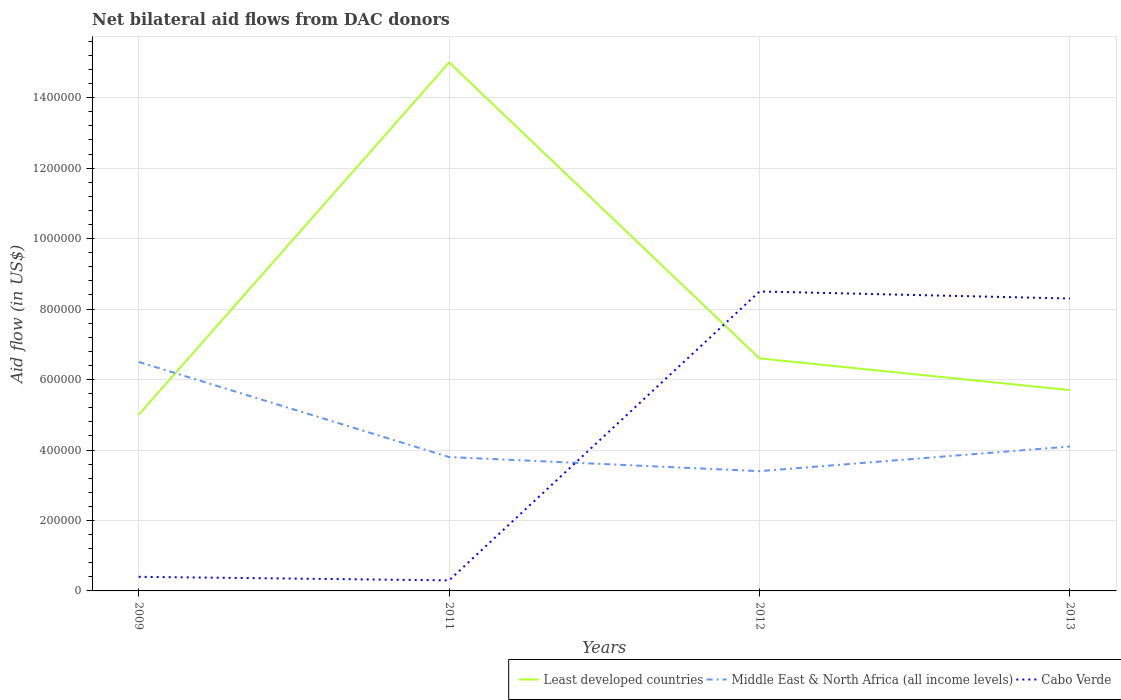Does the line corresponding to Middle East & North Africa (all income levels) intersect with the line corresponding to Least developed countries?
Your answer should be compact. Yes. Is the number of lines equal to the number of legend labels?
Your answer should be compact. Yes. Across all years, what is the maximum net bilateral aid flow in Least developed countries?
Make the answer very short. 5.00e+05. What is the total net bilateral aid flow in Least developed countries in the graph?
Offer a very short reply. -1.60e+05. What is the difference between the highest and the second highest net bilateral aid flow in Cabo Verde?
Your answer should be very brief. 8.20e+05. Is the net bilateral aid flow in Middle East & North Africa (all income levels) strictly greater than the net bilateral aid flow in Least developed countries over the years?
Give a very brief answer. No. Are the values on the major ticks of Y-axis written in scientific E-notation?
Make the answer very short. No. Does the graph contain any zero values?
Offer a very short reply. No. Does the graph contain grids?
Provide a short and direct response. Yes. Where does the legend appear in the graph?
Your response must be concise. Bottom right. What is the title of the graph?
Provide a short and direct response. Net bilateral aid flows from DAC donors. Does "Bulgaria" appear as one of the legend labels in the graph?
Ensure brevity in your answer.  No. What is the label or title of the Y-axis?
Provide a succinct answer. Aid flow (in US$). What is the Aid flow (in US$) in Middle East & North Africa (all income levels) in 2009?
Offer a terse response. 6.50e+05. What is the Aid flow (in US$) in Least developed countries in 2011?
Make the answer very short. 1.50e+06. What is the Aid flow (in US$) of Least developed countries in 2012?
Ensure brevity in your answer.  6.60e+05. What is the Aid flow (in US$) of Cabo Verde in 2012?
Offer a terse response. 8.50e+05. What is the Aid flow (in US$) in Least developed countries in 2013?
Offer a very short reply. 5.70e+05. What is the Aid flow (in US$) of Middle East & North Africa (all income levels) in 2013?
Your answer should be compact. 4.10e+05. What is the Aid flow (in US$) of Cabo Verde in 2013?
Provide a short and direct response. 8.30e+05. Across all years, what is the maximum Aid flow (in US$) in Least developed countries?
Your answer should be compact. 1.50e+06. Across all years, what is the maximum Aid flow (in US$) of Middle East & North Africa (all income levels)?
Make the answer very short. 6.50e+05. Across all years, what is the maximum Aid flow (in US$) of Cabo Verde?
Your answer should be compact. 8.50e+05. Across all years, what is the minimum Aid flow (in US$) in Least developed countries?
Keep it short and to the point. 5.00e+05. Across all years, what is the minimum Aid flow (in US$) in Middle East & North Africa (all income levels)?
Provide a short and direct response. 3.40e+05. Across all years, what is the minimum Aid flow (in US$) of Cabo Verde?
Ensure brevity in your answer.  3.00e+04. What is the total Aid flow (in US$) in Least developed countries in the graph?
Keep it short and to the point. 3.23e+06. What is the total Aid flow (in US$) of Middle East & North Africa (all income levels) in the graph?
Keep it short and to the point. 1.78e+06. What is the total Aid flow (in US$) of Cabo Verde in the graph?
Your answer should be very brief. 1.75e+06. What is the difference between the Aid flow (in US$) of Least developed countries in 2009 and that in 2011?
Your response must be concise. -1.00e+06. What is the difference between the Aid flow (in US$) in Middle East & North Africa (all income levels) in 2009 and that in 2011?
Keep it short and to the point. 2.70e+05. What is the difference between the Aid flow (in US$) of Cabo Verde in 2009 and that in 2012?
Make the answer very short. -8.10e+05. What is the difference between the Aid flow (in US$) of Middle East & North Africa (all income levels) in 2009 and that in 2013?
Ensure brevity in your answer.  2.40e+05. What is the difference between the Aid flow (in US$) of Cabo Verde in 2009 and that in 2013?
Make the answer very short. -7.90e+05. What is the difference between the Aid flow (in US$) of Least developed countries in 2011 and that in 2012?
Your answer should be compact. 8.40e+05. What is the difference between the Aid flow (in US$) of Middle East & North Africa (all income levels) in 2011 and that in 2012?
Provide a short and direct response. 4.00e+04. What is the difference between the Aid flow (in US$) of Cabo Verde in 2011 and that in 2012?
Provide a succinct answer. -8.20e+05. What is the difference between the Aid flow (in US$) in Least developed countries in 2011 and that in 2013?
Keep it short and to the point. 9.30e+05. What is the difference between the Aid flow (in US$) in Middle East & North Africa (all income levels) in 2011 and that in 2013?
Offer a very short reply. -3.00e+04. What is the difference between the Aid flow (in US$) of Cabo Verde in 2011 and that in 2013?
Your answer should be compact. -8.00e+05. What is the difference between the Aid flow (in US$) in Least developed countries in 2012 and that in 2013?
Give a very brief answer. 9.00e+04. What is the difference between the Aid flow (in US$) of Middle East & North Africa (all income levels) in 2012 and that in 2013?
Give a very brief answer. -7.00e+04. What is the difference between the Aid flow (in US$) in Least developed countries in 2009 and the Aid flow (in US$) in Middle East & North Africa (all income levels) in 2011?
Give a very brief answer. 1.20e+05. What is the difference between the Aid flow (in US$) of Least developed countries in 2009 and the Aid flow (in US$) of Cabo Verde in 2011?
Your response must be concise. 4.70e+05. What is the difference between the Aid flow (in US$) in Middle East & North Africa (all income levels) in 2009 and the Aid flow (in US$) in Cabo Verde in 2011?
Offer a very short reply. 6.20e+05. What is the difference between the Aid flow (in US$) in Least developed countries in 2009 and the Aid flow (in US$) in Cabo Verde in 2012?
Your response must be concise. -3.50e+05. What is the difference between the Aid flow (in US$) of Least developed countries in 2009 and the Aid flow (in US$) of Middle East & North Africa (all income levels) in 2013?
Keep it short and to the point. 9.00e+04. What is the difference between the Aid flow (in US$) in Least developed countries in 2009 and the Aid flow (in US$) in Cabo Verde in 2013?
Offer a terse response. -3.30e+05. What is the difference between the Aid flow (in US$) of Middle East & North Africa (all income levels) in 2009 and the Aid flow (in US$) of Cabo Verde in 2013?
Make the answer very short. -1.80e+05. What is the difference between the Aid flow (in US$) of Least developed countries in 2011 and the Aid flow (in US$) of Middle East & North Africa (all income levels) in 2012?
Provide a short and direct response. 1.16e+06. What is the difference between the Aid flow (in US$) in Least developed countries in 2011 and the Aid flow (in US$) in Cabo Verde in 2012?
Ensure brevity in your answer.  6.50e+05. What is the difference between the Aid flow (in US$) in Middle East & North Africa (all income levels) in 2011 and the Aid flow (in US$) in Cabo Verde in 2012?
Offer a terse response. -4.70e+05. What is the difference between the Aid flow (in US$) of Least developed countries in 2011 and the Aid flow (in US$) of Middle East & North Africa (all income levels) in 2013?
Give a very brief answer. 1.09e+06. What is the difference between the Aid flow (in US$) of Least developed countries in 2011 and the Aid flow (in US$) of Cabo Verde in 2013?
Offer a terse response. 6.70e+05. What is the difference between the Aid flow (in US$) in Middle East & North Africa (all income levels) in 2011 and the Aid flow (in US$) in Cabo Verde in 2013?
Your answer should be very brief. -4.50e+05. What is the difference between the Aid flow (in US$) in Least developed countries in 2012 and the Aid flow (in US$) in Middle East & North Africa (all income levels) in 2013?
Keep it short and to the point. 2.50e+05. What is the difference between the Aid flow (in US$) in Least developed countries in 2012 and the Aid flow (in US$) in Cabo Verde in 2013?
Provide a succinct answer. -1.70e+05. What is the difference between the Aid flow (in US$) in Middle East & North Africa (all income levels) in 2012 and the Aid flow (in US$) in Cabo Verde in 2013?
Give a very brief answer. -4.90e+05. What is the average Aid flow (in US$) of Least developed countries per year?
Offer a terse response. 8.08e+05. What is the average Aid flow (in US$) of Middle East & North Africa (all income levels) per year?
Your response must be concise. 4.45e+05. What is the average Aid flow (in US$) in Cabo Verde per year?
Your answer should be compact. 4.38e+05. In the year 2009, what is the difference between the Aid flow (in US$) of Least developed countries and Aid flow (in US$) of Cabo Verde?
Your answer should be very brief. 4.60e+05. In the year 2011, what is the difference between the Aid flow (in US$) in Least developed countries and Aid flow (in US$) in Middle East & North Africa (all income levels)?
Make the answer very short. 1.12e+06. In the year 2011, what is the difference between the Aid flow (in US$) of Least developed countries and Aid flow (in US$) of Cabo Verde?
Offer a terse response. 1.47e+06. In the year 2011, what is the difference between the Aid flow (in US$) in Middle East & North Africa (all income levels) and Aid flow (in US$) in Cabo Verde?
Provide a short and direct response. 3.50e+05. In the year 2012, what is the difference between the Aid flow (in US$) of Least developed countries and Aid flow (in US$) of Middle East & North Africa (all income levels)?
Offer a terse response. 3.20e+05. In the year 2012, what is the difference between the Aid flow (in US$) of Least developed countries and Aid flow (in US$) of Cabo Verde?
Offer a terse response. -1.90e+05. In the year 2012, what is the difference between the Aid flow (in US$) in Middle East & North Africa (all income levels) and Aid flow (in US$) in Cabo Verde?
Your answer should be very brief. -5.10e+05. In the year 2013, what is the difference between the Aid flow (in US$) in Least developed countries and Aid flow (in US$) in Middle East & North Africa (all income levels)?
Offer a very short reply. 1.60e+05. In the year 2013, what is the difference between the Aid flow (in US$) of Least developed countries and Aid flow (in US$) of Cabo Verde?
Your answer should be compact. -2.60e+05. In the year 2013, what is the difference between the Aid flow (in US$) in Middle East & North Africa (all income levels) and Aid flow (in US$) in Cabo Verde?
Offer a terse response. -4.20e+05. What is the ratio of the Aid flow (in US$) of Least developed countries in 2009 to that in 2011?
Keep it short and to the point. 0.33. What is the ratio of the Aid flow (in US$) in Middle East & North Africa (all income levels) in 2009 to that in 2011?
Keep it short and to the point. 1.71. What is the ratio of the Aid flow (in US$) in Cabo Verde in 2009 to that in 2011?
Provide a succinct answer. 1.33. What is the ratio of the Aid flow (in US$) of Least developed countries in 2009 to that in 2012?
Keep it short and to the point. 0.76. What is the ratio of the Aid flow (in US$) of Middle East & North Africa (all income levels) in 2009 to that in 2012?
Keep it short and to the point. 1.91. What is the ratio of the Aid flow (in US$) in Cabo Verde in 2009 to that in 2012?
Your response must be concise. 0.05. What is the ratio of the Aid flow (in US$) in Least developed countries in 2009 to that in 2013?
Keep it short and to the point. 0.88. What is the ratio of the Aid flow (in US$) in Middle East & North Africa (all income levels) in 2009 to that in 2013?
Offer a terse response. 1.59. What is the ratio of the Aid flow (in US$) of Cabo Verde in 2009 to that in 2013?
Offer a very short reply. 0.05. What is the ratio of the Aid flow (in US$) of Least developed countries in 2011 to that in 2012?
Your answer should be compact. 2.27. What is the ratio of the Aid flow (in US$) of Middle East & North Africa (all income levels) in 2011 to that in 2012?
Your response must be concise. 1.12. What is the ratio of the Aid flow (in US$) in Cabo Verde in 2011 to that in 2012?
Give a very brief answer. 0.04. What is the ratio of the Aid flow (in US$) in Least developed countries in 2011 to that in 2013?
Provide a succinct answer. 2.63. What is the ratio of the Aid flow (in US$) in Middle East & North Africa (all income levels) in 2011 to that in 2013?
Provide a succinct answer. 0.93. What is the ratio of the Aid flow (in US$) of Cabo Verde in 2011 to that in 2013?
Offer a terse response. 0.04. What is the ratio of the Aid flow (in US$) of Least developed countries in 2012 to that in 2013?
Your answer should be very brief. 1.16. What is the ratio of the Aid flow (in US$) in Middle East & North Africa (all income levels) in 2012 to that in 2013?
Make the answer very short. 0.83. What is the ratio of the Aid flow (in US$) of Cabo Verde in 2012 to that in 2013?
Keep it short and to the point. 1.02. What is the difference between the highest and the second highest Aid flow (in US$) in Least developed countries?
Your response must be concise. 8.40e+05. What is the difference between the highest and the second highest Aid flow (in US$) of Cabo Verde?
Keep it short and to the point. 2.00e+04. What is the difference between the highest and the lowest Aid flow (in US$) of Cabo Verde?
Offer a terse response. 8.20e+05. 